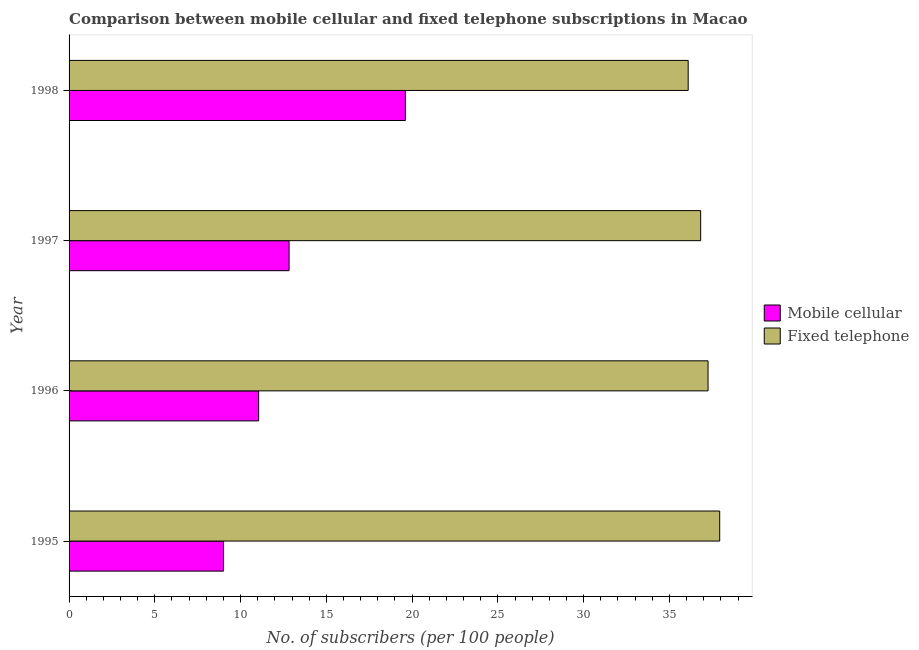How many different coloured bars are there?
Provide a short and direct response. 2. How many groups of bars are there?
Offer a terse response. 4. How many bars are there on the 2nd tick from the top?
Provide a succinct answer. 2. How many bars are there on the 1st tick from the bottom?
Make the answer very short. 2. What is the label of the 2nd group of bars from the top?
Offer a terse response. 1997. What is the number of fixed telephone subscribers in 1997?
Offer a terse response. 36.82. Across all years, what is the maximum number of mobile cellular subscribers?
Your response must be concise. 19.61. Across all years, what is the minimum number of mobile cellular subscribers?
Keep it short and to the point. 9. In which year was the number of mobile cellular subscribers minimum?
Provide a short and direct response. 1995. What is the total number of fixed telephone subscribers in the graph?
Your response must be concise. 148.09. What is the difference between the number of fixed telephone subscribers in 1996 and that in 1997?
Offer a terse response. 0.43. What is the difference between the number of fixed telephone subscribers in 1997 and the number of mobile cellular subscribers in 1996?
Make the answer very short. 25.77. What is the average number of fixed telephone subscribers per year?
Your response must be concise. 37.02. In the year 1996, what is the difference between the number of fixed telephone subscribers and number of mobile cellular subscribers?
Provide a short and direct response. 26.2. What is the ratio of the number of fixed telephone subscribers in 1997 to that in 1998?
Give a very brief answer. 1.02. Is the difference between the number of fixed telephone subscribers in 1996 and 1998 greater than the difference between the number of mobile cellular subscribers in 1996 and 1998?
Your response must be concise. Yes. What is the difference between the highest and the second highest number of fixed telephone subscribers?
Provide a short and direct response. 0.68. In how many years, is the number of fixed telephone subscribers greater than the average number of fixed telephone subscribers taken over all years?
Ensure brevity in your answer.  2. Is the sum of the number of fixed telephone subscribers in 1995 and 1998 greater than the maximum number of mobile cellular subscribers across all years?
Provide a succinct answer. Yes. What does the 1st bar from the top in 1997 represents?
Keep it short and to the point. Fixed telephone. What does the 2nd bar from the bottom in 1995 represents?
Offer a terse response. Fixed telephone. Are all the bars in the graph horizontal?
Offer a very short reply. Yes. What is the difference between two consecutive major ticks on the X-axis?
Your response must be concise. 5. Are the values on the major ticks of X-axis written in scientific E-notation?
Ensure brevity in your answer.  No. Does the graph contain any zero values?
Offer a terse response. No. Where does the legend appear in the graph?
Provide a short and direct response. Center right. How many legend labels are there?
Offer a terse response. 2. How are the legend labels stacked?
Provide a succinct answer. Vertical. What is the title of the graph?
Offer a terse response. Comparison between mobile cellular and fixed telephone subscriptions in Macao. Does "National Visitors" appear as one of the legend labels in the graph?
Your answer should be very brief. No. What is the label or title of the X-axis?
Make the answer very short. No. of subscribers (per 100 people). What is the label or title of the Y-axis?
Offer a very short reply. Year. What is the No. of subscribers (per 100 people) in Mobile cellular in 1995?
Your answer should be very brief. 9. What is the No. of subscribers (per 100 people) in Fixed telephone in 1995?
Give a very brief answer. 37.93. What is the No. of subscribers (per 100 people) in Mobile cellular in 1996?
Provide a short and direct response. 11.05. What is the No. of subscribers (per 100 people) of Fixed telephone in 1996?
Give a very brief answer. 37.25. What is the No. of subscribers (per 100 people) of Mobile cellular in 1997?
Ensure brevity in your answer.  12.83. What is the No. of subscribers (per 100 people) in Fixed telephone in 1997?
Make the answer very short. 36.82. What is the No. of subscribers (per 100 people) in Mobile cellular in 1998?
Provide a short and direct response. 19.61. What is the No. of subscribers (per 100 people) in Fixed telephone in 1998?
Offer a very short reply. 36.09. Across all years, what is the maximum No. of subscribers (per 100 people) of Mobile cellular?
Ensure brevity in your answer.  19.61. Across all years, what is the maximum No. of subscribers (per 100 people) of Fixed telephone?
Keep it short and to the point. 37.93. Across all years, what is the minimum No. of subscribers (per 100 people) of Mobile cellular?
Your answer should be compact. 9. Across all years, what is the minimum No. of subscribers (per 100 people) in Fixed telephone?
Your answer should be compact. 36.09. What is the total No. of subscribers (per 100 people) in Mobile cellular in the graph?
Give a very brief answer. 52.49. What is the total No. of subscribers (per 100 people) in Fixed telephone in the graph?
Make the answer very short. 148.09. What is the difference between the No. of subscribers (per 100 people) of Mobile cellular in 1995 and that in 1996?
Your answer should be compact. -2.05. What is the difference between the No. of subscribers (per 100 people) of Fixed telephone in 1995 and that in 1996?
Ensure brevity in your answer.  0.68. What is the difference between the No. of subscribers (per 100 people) in Mobile cellular in 1995 and that in 1997?
Provide a short and direct response. -3.82. What is the difference between the No. of subscribers (per 100 people) in Fixed telephone in 1995 and that in 1997?
Your answer should be very brief. 1.11. What is the difference between the No. of subscribers (per 100 people) of Mobile cellular in 1995 and that in 1998?
Ensure brevity in your answer.  -10.6. What is the difference between the No. of subscribers (per 100 people) of Fixed telephone in 1995 and that in 1998?
Provide a short and direct response. 1.84. What is the difference between the No. of subscribers (per 100 people) in Mobile cellular in 1996 and that in 1997?
Offer a terse response. -1.77. What is the difference between the No. of subscribers (per 100 people) in Fixed telephone in 1996 and that in 1997?
Your answer should be compact. 0.43. What is the difference between the No. of subscribers (per 100 people) in Mobile cellular in 1996 and that in 1998?
Make the answer very short. -8.55. What is the difference between the No. of subscribers (per 100 people) of Fixed telephone in 1996 and that in 1998?
Your response must be concise. 1.16. What is the difference between the No. of subscribers (per 100 people) in Mobile cellular in 1997 and that in 1998?
Keep it short and to the point. -6.78. What is the difference between the No. of subscribers (per 100 people) in Fixed telephone in 1997 and that in 1998?
Make the answer very short. 0.73. What is the difference between the No. of subscribers (per 100 people) in Mobile cellular in 1995 and the No. of subscribers (per 100 people) in Fixed telephone in 1996?
Your answer should be very brief. -28.25. What is the difference between the No. of subscribers (per 100 people) of Mobile cellular in 1995 and the No. of subscribers (per 100 people) of Fixed telephone in 1997?
Offer a terse response. -27.82. What is the difference between the No. of subscribers (per 100 people) in Mobile cellular in 1995 and the No. of subscribers (per 100 people) in Fixed telephone in 1998?
Provide a short and direct response. -27.09. What is the difference between the No. of subscribers (per 100 people) of Mobile cellular in 1996 and the No. of subscribers (per 100 people) of Fixed telephone in 1997?
Provide a succinct answer. -25.77. What is the difference between the No. of subscribers (per 100 people) of Mobile cellular in 1996 and the No. of subscribers (per 100 people) of Fixed telephone in 1998?
Give a very brief answer. -25.04. What is the difference between the No. of subscribers (per 100 people) in Mobile cellular in 1997 and the No. of subscribers (per 100 people) in Fixed telephone in 1998?
Ensure brevity in your answer.  -23.27. What is the average No. of subscribers (per 100 people) of Mobile cellular per year?
Ensure brevity in your answer.  13.12. What is the average No. of subscribers (per 100 people) in Fixed telephone per year?
Offer a very short reply. 37.02. In the year 1995, what is the difference between the No. of subscribers (per 100 people) of Mobile cellular and No. of subscribers (per 100 people) of Fixed telephone?
Give a very brief answer. -28.93. In the year 1996, what is the difference between the No. of subscribers (per 100 people) in Mobile cellular and No. of subscribers (per 100 people) in Fixed telephone?
Your response must be concise. -26.2. In the year 1997, what is the difference between the No. of subscribers (per 100 people) in Mobile cellular and No. of subscribers (per 100 people) in Fixed telephone?
Make the answer very short. -23.99. In the year 1998, what is the difference between the No. of subscribers (per 100 people) in Mobile cellular and No. of subscribers (per 100 people) in Fixed telephone?
Provide a short and direct response. -16.49. What is the ratio of the No. of subscribers (per 100 people) in Mobile cellular in 1995 to that in 1996?
Give a very brief answer. 0.81. What is the ratio of the No. of subscribers (per 100 people) in Fixed telephone in 1995 to that in 1996?
Offer a terse response. 1.02. What is the ratio of the No. of subscribers (per 100 people) of Mobile cellular in 1995 to that in 1997?
Keep it short and to the point. 0.7. What is the ratio of the No. of subscribers (per 100 people) of Fixed telephone in 1995 to that in 1997?
Ensure brevity in your answer.  1.03. What is the ratio of the No. of subscribers (per 100 people) of Mobile cellular in 1995 to that in 1998?
Give a very brief answer. 0.46. What is the ratio of the No. of subscribers (per 100 people) of Fixed telephone in 1995 to that in 1998?
Your answer should be very brief. 1.05. What is the ratio of the No. of subscribers (per 100 people) of Mobile cellular in 1996 to that in 1997?
Your answer should be very brief. 0.86. What is the ratio of the No. of subscribers (per 100 people) in Fixed telephone in 1996 to that in 1997?
Your response must be concise. 1.01. What is the ratio of the No. of subscribers (per 100 people) of Mobile cellular in 1996 to that in 1998?
Your answer should be compact. 0.56. What is the ratio of the No. of subscribers (per 100 people) in Fixed telephone in 1996 to that in 1998?
Your answer should be very brief. 1.03. What is the ratio of the No. of subscribers (per 100 people) of Mobile cellular in 1997 to that in 1998?
Offer a terse response. 0.65. What is the ratio of the No. of subscribers (per 100 people) in Fixed telephone in 1997 to that in 1998?
Offer a terse response. 1.02. What is the difference between the highest and the second highest No. of subscribers (per 100 people) in Mobile cellular?
Offer a very short reply. 6.78. What is the difference between the highest and the second highest No. of subscribers (per 100 people) in Fixed telephone?
Offer a terse response. 0.68. What is the difference between the highest and the lowest No. of subscribers (per 100 people) of Mobile cellular?
Provide a short and direct response. 10.6. What is the difference between the highest and the lowest No. of subscribers (per 100 people) in Fixed telephone?
Keep it short and to the point. 1.84. 